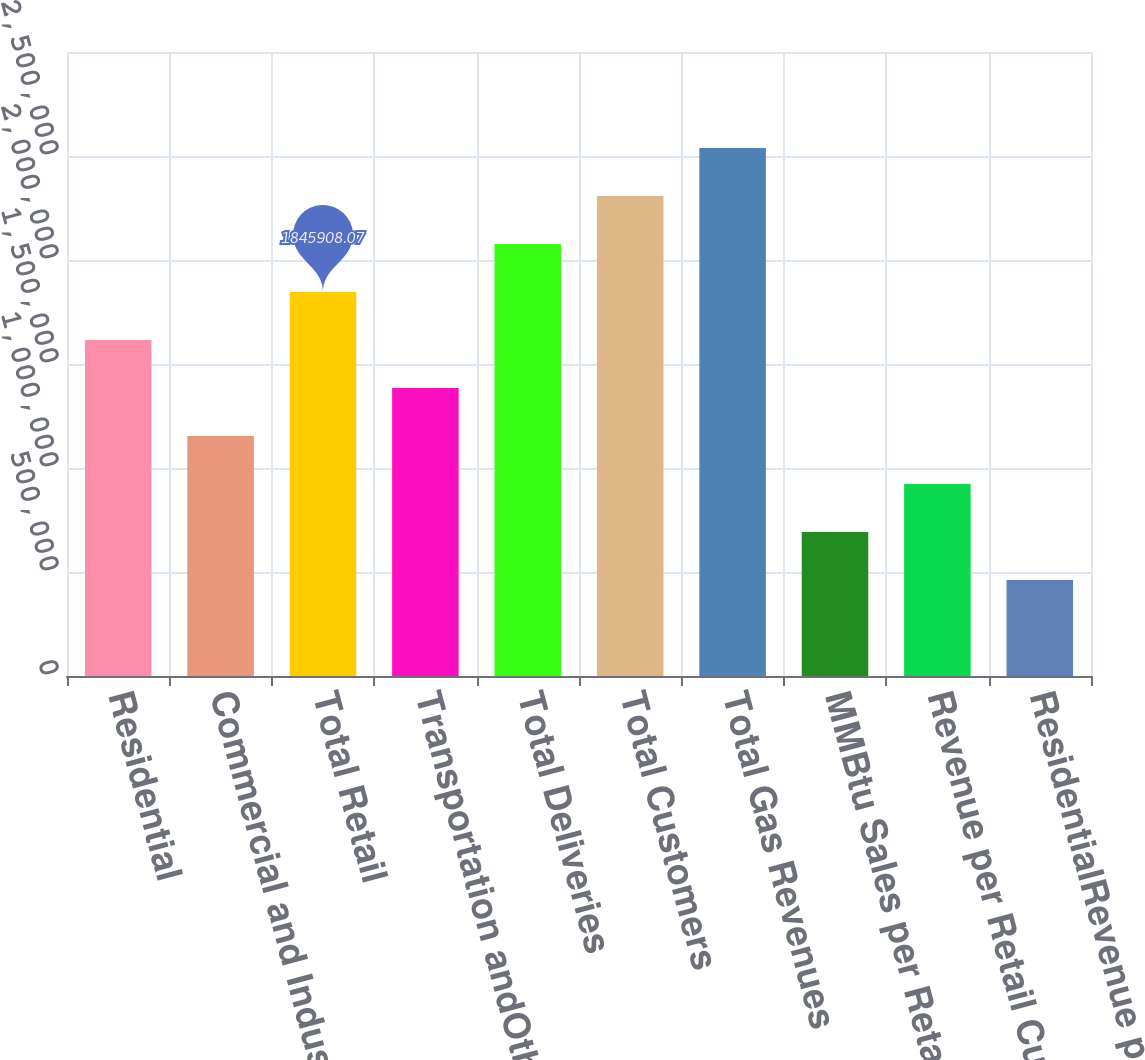Convert chart to OTSL. <chart><loc_0><loc_0><loc_500><loc_500><bar_chart><fcel>Residential<fcel>Commercial and Industrial<fcel>Total Retail<fcel>Transportation andOther<fcel>Total Deliveries<fcel>Total Customers<fcel>Total Gas Revenues<fcel>MMBtu Sales per Retail<fcel>Revenue per Retail Customer<fcel>ResidentialRevenue per MMBtu<nl><fcel>1.61517e+06<fcel>1.15369e+06<fcel>1.84591e+06<fcel>1.38443e+06<fcel>2.07665e+06<fcel>2.30738e+06<fcel>2.53812e+06<fcel>692216<fcel>922954<fcel>461477<nl></chart> 